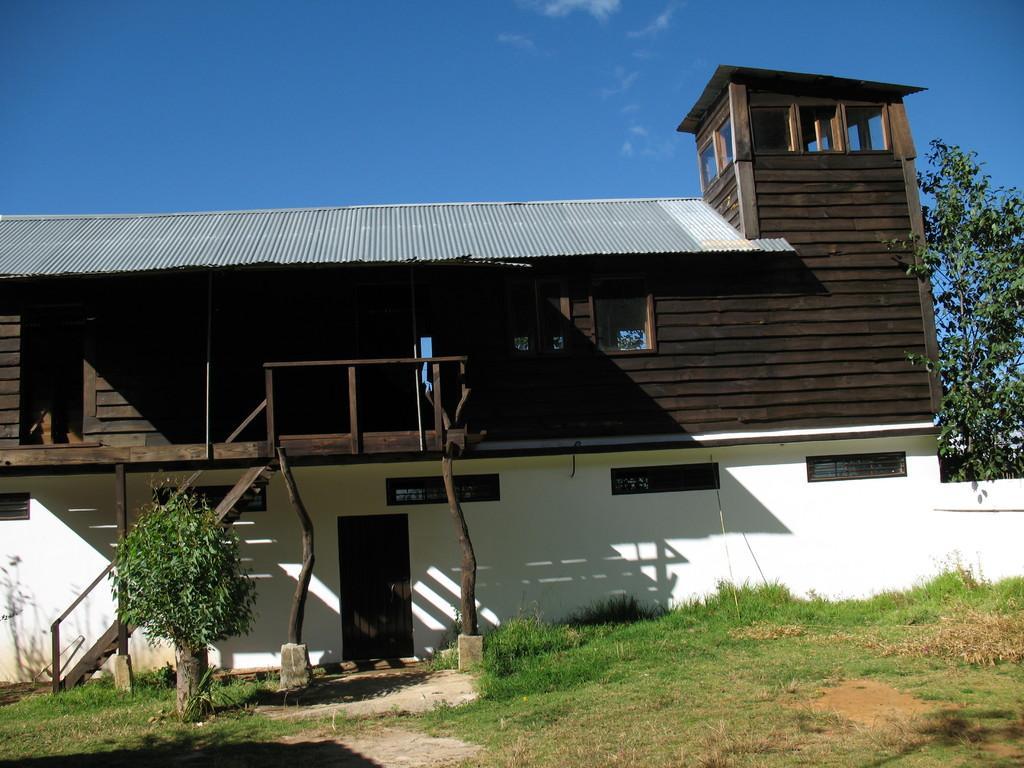Can you describe this image briefly? This image is taken outdoors. At the bottom of the image there is a ground with grass on it. At the top of the image there is a sky with clouds. In the middle of the image there is a house with a few walls, windows, roofs and door and there is a plant and a tree. 